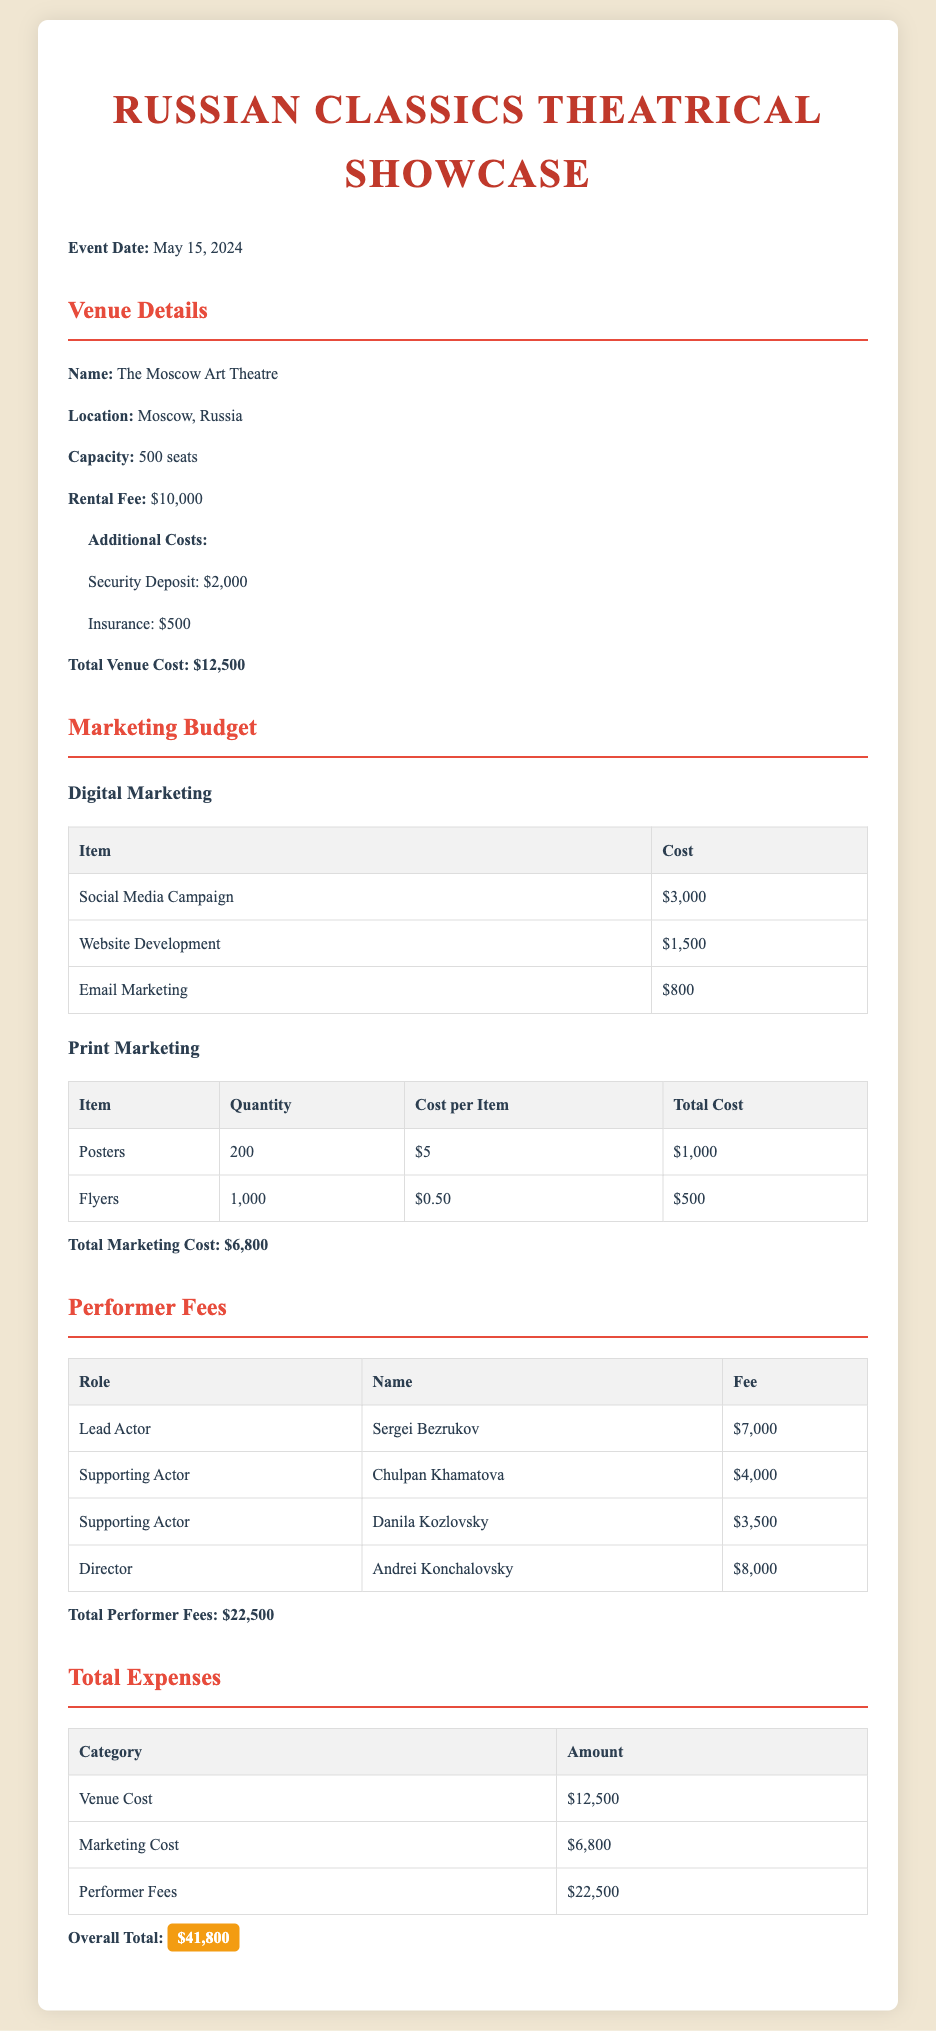What is the event date? The event date is specified earlier in the document for the theatrical showcase as May 15, 2024.
Answer: May 15, 2024 What is the venue name? The venue name for the theatrical showcase is mentioned as The Moscow Art Theatre.
Answer: The Moscow Art Theatre What is the rental fee for the venue? The rental fee for the venue is listed in the venue details as $10,000.
Answer: $10,000 What is the total marketing cost? The total marketing cost is calculated by adding up all the expenses listed under marketing, which amounts to $6,800.
Answer: $6,800 Who is the lead actor? The document specifies that the lead actor for the performance is Sergei Bezrukov.
Answer: Sergei Bezrukov What is the total performer fees? The total performer fees are calculated by summing all the fees of the performers listed in the document, resulting in $22,500.
Answer: $22,500 What is the total venue cost including additional costs? The total venue cost, including the rental fee and additional costs, is given as $12,500.
Answer: $12,500 What is the overall total expense for the event? The overall total expense is provided in the document and totals $41,800.
Answer: $41,800 